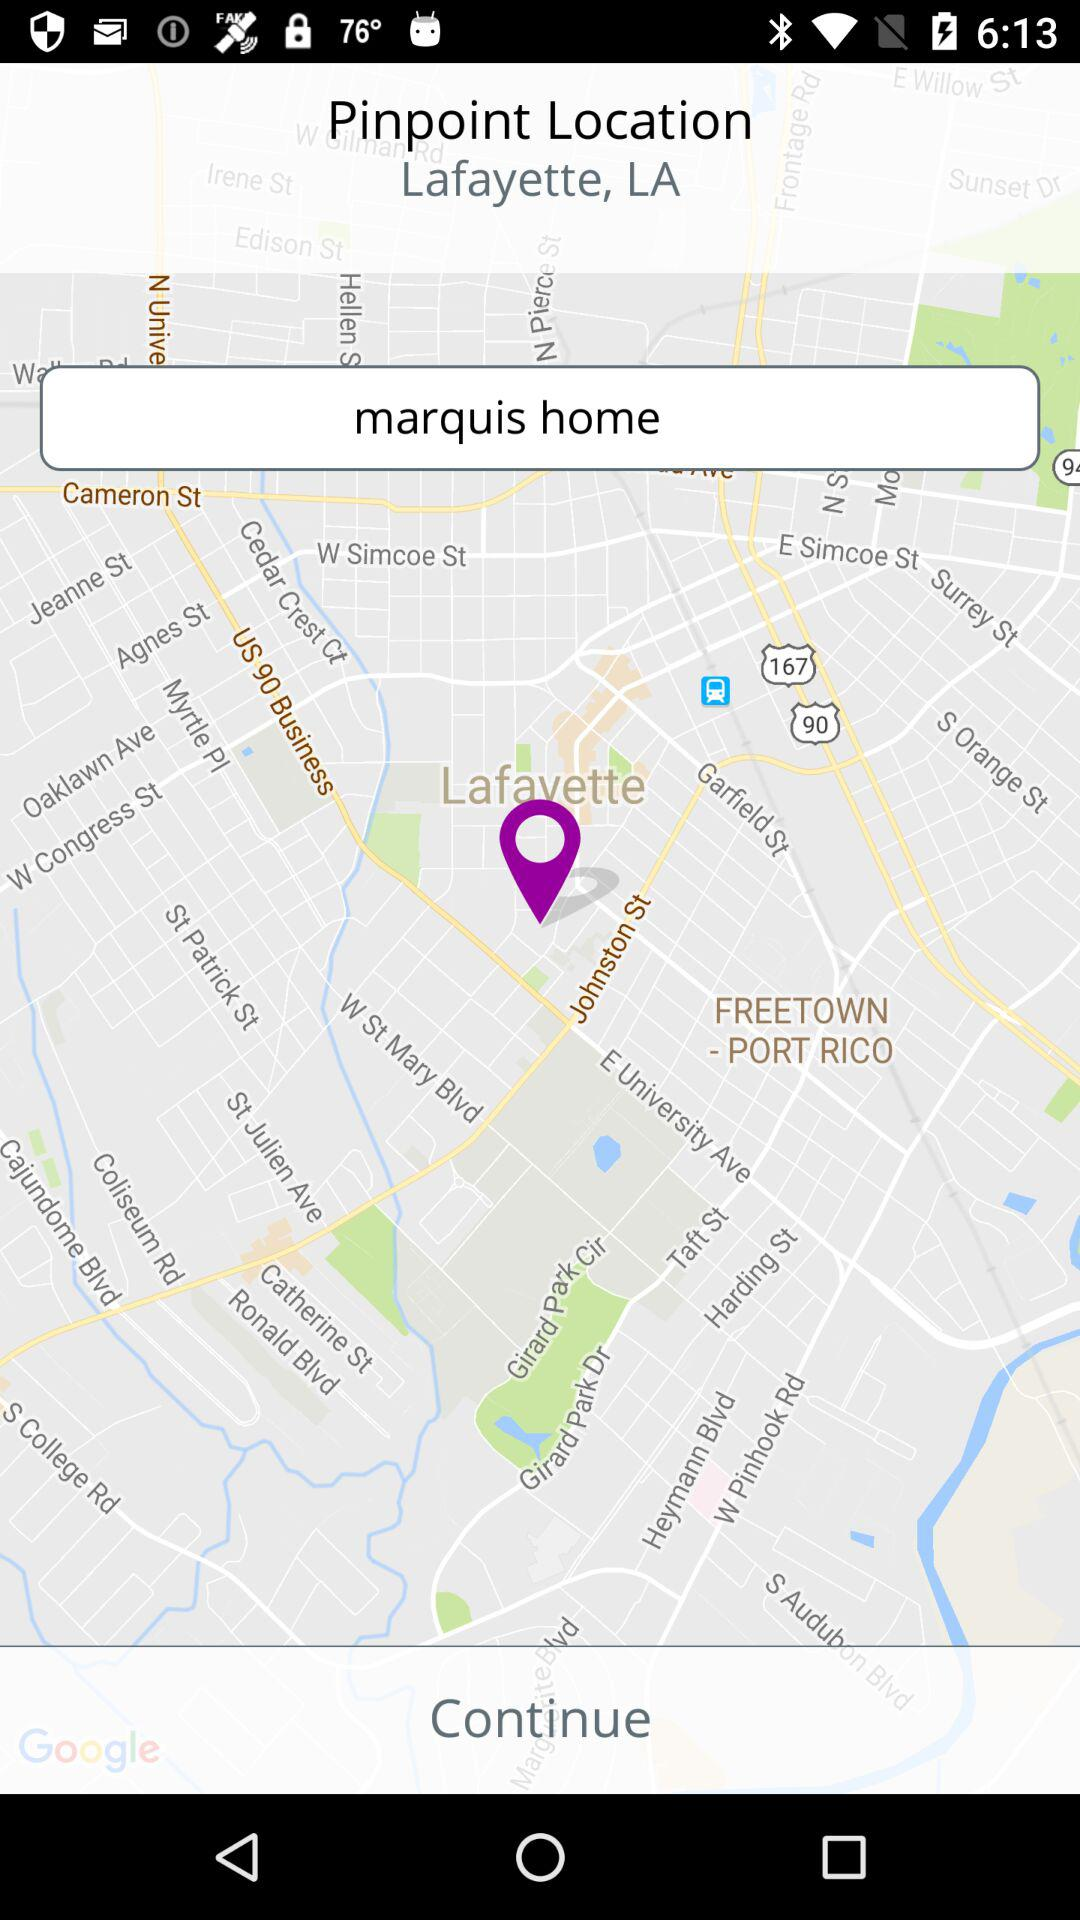What is the street address?
When the provided information is insufficient, respond with <no answer>. <no answer> 